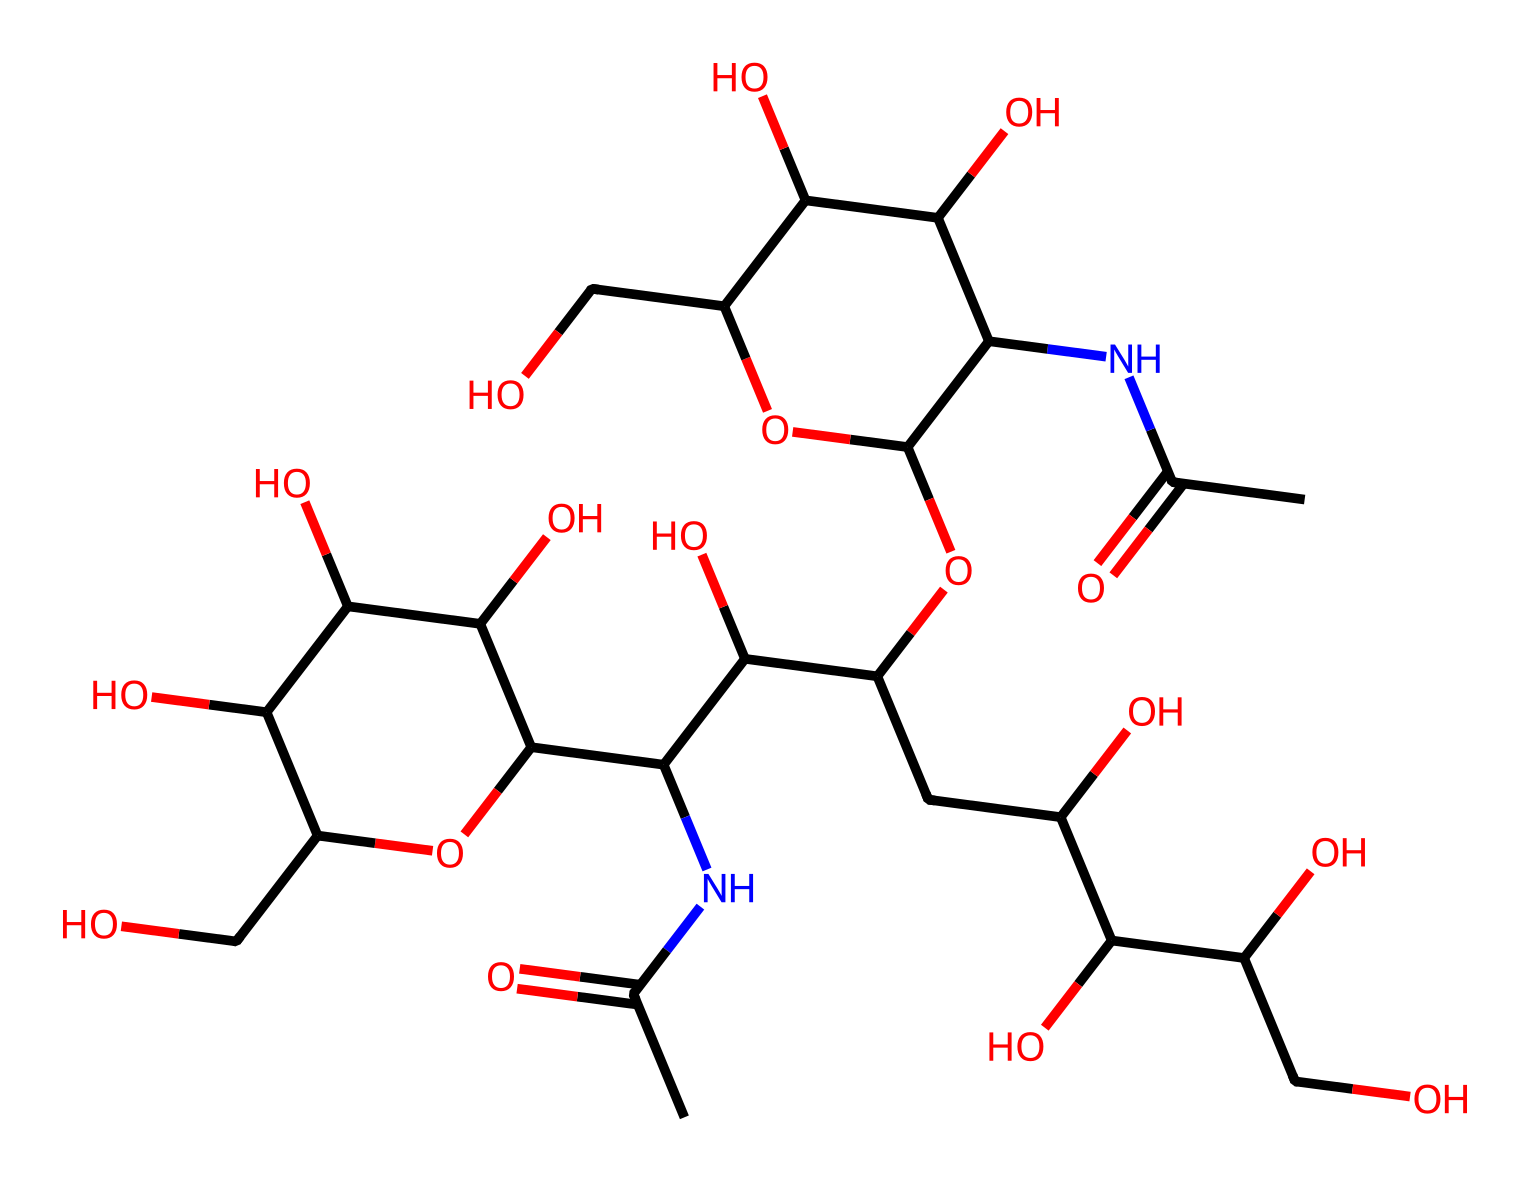What is the primary component that gives hyaluronic acid its moisturizing properties? The chemical structure of hyaluronic acid contains multiple hydroxyl (-OH) groups, which are responsible for its ability to retain moisture.
Answer: hydroxyl groups How many nitrogen atoms are present in this hyaluronic acid structure? By examining the SMILES representation, we identify only one nitrogen atom present in the amide functional group (NC).
Answer: 1 What is the main function of hyaluronic acid in cosmetic products? Hyaluronic acid primarily functions to hydrate the skin by attracting and holding moisture, which is crucial for combating dryness.
Answer: hydrate Which part of this structure makes hyaluronic acid a polymer? The presence of repeating disaccharide units linked by glycosidic bonds characterizes hyaluronic acid as a polymer.
Answer: disaccharide units How many hydroxyl groups are present in the chemical structure of hyaluronic acid? By analyzing the structure, we count multiple hydroxyl groups that contribute to its polarity and hydration capacity; the count is 6.
Answer: 6 